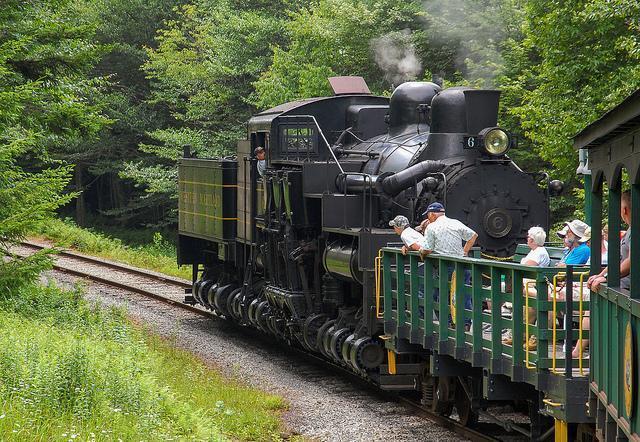How many times do you see the number 6?
Give a very brief answer. 1. How many bears are wearing a hat in the picture?
Give a very brief answer. 0. 